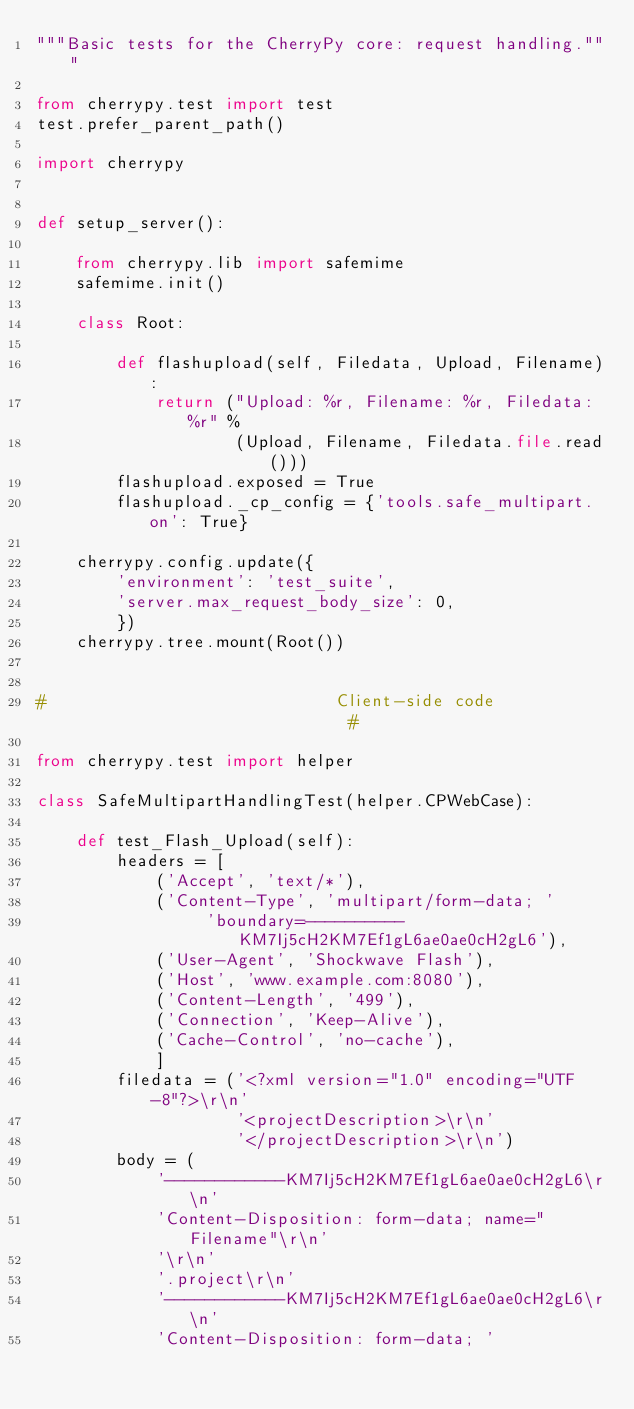Convert code to text. <code><loc_0><loc_0><loc_500><loc_500><_Python_>"""Basic tests for the CherryPy core: request handling."""

from cherrypy.test import test
test.prefer_parent_path()

import cherrypy


def setup_server():
    
    from cherrypy.lib import safemime
    safemime.init()
    
    class Root:
        
        def flashupload(self, Filedata, Upload, Filename):
            return ("Upload: %r, Filename: %r, Filedata: %r" %
                    (Upload, Filename, Filedata.file.read()))
        flashupload.exposed = True
        flashupload._cp_config = {'tools.safe_multipart.on': True}
    
    cherrypy.config.update({
        'environment': 'test_suite',
        'server.max_request_body_size': 0,
        })
    cherrypy.tree.mount(Root())


#                             Client-side code                             #

from cherrypy.test import helper

class SafeMultipartHandlingTest(helper.CPWebCase):
    
    def test_Flash_Upload(self):
        headers = [
            ('Accept', 'text/*'),
            ('Content-Type', 'multipart/form-data; '
                 'boundary=----------KM7Ij5cH2KM7Ef1gL6ae0ae0cH2gL6'),
            ('User-Agent', 'Shockwave Flash'),
            ('Host', 'www.example.com:8080'),
            ('Content-Length', '499'),
            ('Connection', 'Keep-Alive'),
            ('Cache-Control', 'no-cache'),
            ]
        filedata = ('<?xml version="1.0" encoding="UTF-8"?>\r\n'
                    '<projectDescription>\r\n'
                    '</projectDescription>\r\n')
        body = (
            '------------KM7Ij5cH2KM7Ef1gL6ae0ae0cH2gL6\r\n'
            'Content-Disposition: form-data; name="Filename"\r\n'
            '\r\n'
            '.project\r\n'
            '------------KM7Ij5cH2KM7Ef1gL6ae0ae0cH2gL6\r\n'
            'Content-Disposition: form-data; '</code> 